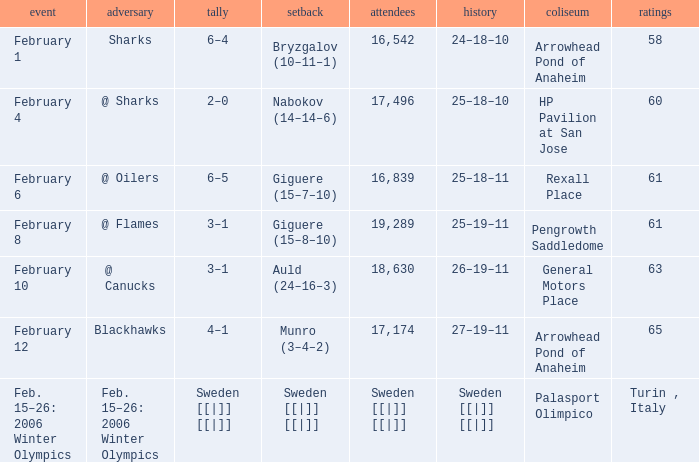What is the record at Palasport Olimpico? Sweden [[|]] [[|]]. 